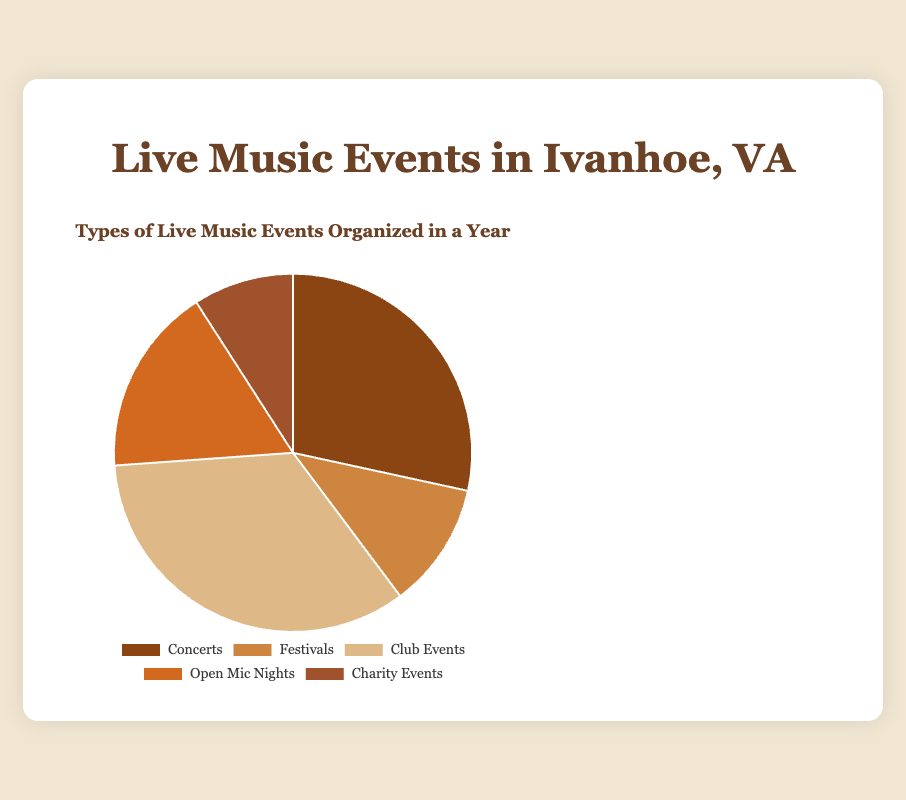Which type of event makes up the largest share of live music events? By looking at the pie chart, the segment with the largest area will have the largest share. In this chart, the segment for Club Events is the largest.
Answer: Club Events How many more Club Events are there compared to Concerts? Count the number of events for Club Events and Concerts. Club Events have 30 events, and Concerts have 25. The difference is 30 - 25 = 5.
Answer: 5 What percentage of the total are the Open Mic Nights? Sum the total number of events: 25 + 10 + 30 + 15 + 8 = 88. The percentage of Open Mic Nights is (15 / 88) * 100 ≈ 17.05%.
Answer: 17.05% Arrange the event types from highest to lowest number of events. Compare each segment representing different event types. Club Events (30), Concerts (25), Open Mic Nights (15), Festivals (10), Charity Events (8).
Answer: Club Events, Concerts, Open Mic Nights, Festivals, Charity Events What is the combined number of Festival and Charity Events? Add the number of Festival and Charity Events. Festivals have 10 events, and Charity Events have 8. The total is 10 + 8 = 18.
Answer: 18 Which event type has the smallest share, and what is its count? Find the smallest segment on the pie chart. Charity Events have the smallest area with a count of 8 events.
Answer: Charity Events, 8 What are the total number of events organized by Ivanhoe River Amphitheater, Historic Davis-Bourne Inn, and Ivanhoe Community Center? All these entities organize Concerts. The total number of Concert events is given as 25.
Answer: 25 Are Concerts more frequent than Festivals? Compare the counts from the pie chart. Concerts have 25 events, and Festivals have 10. Therefore, Concerts are more frequent.
Answer: Yes If you were to add 5 more Open Mic Nights, would their total exceed that of Concerts? Current Open Mic Nights are 15. After adding 5, the total is 15 + 5 = 20. Compare this with Concerts, which have 25 events. 20 is less than 25, so it will not exceed.
Answer: No How many total events are there? Add up the counts of all types: 25 (Concerts) + 10 (Festivals) + 30 (Club Events) + 15 (Open Mic Nights) + 8 (Charity Events). The total is 25 + 10 + 30 + 15 + 8 = 88.
Answer: 88 